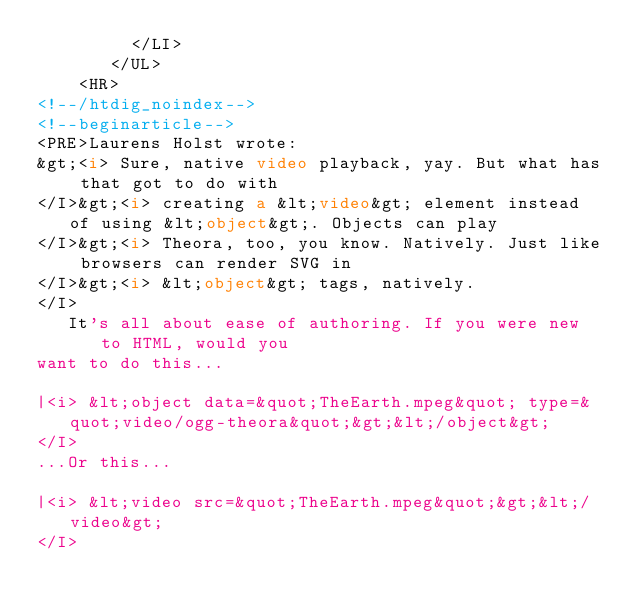Convert code to text. <code><loc_0><loc_0><loc_500><loc_500><_HTML_>         </LI>
       </UL>
    <HR>  
<!--/htdig_noindex-->
<!--beginarticle-->
<PRE>Laurens Holst wrote:
&gt;<i> Sure, native video playback, yay. But what has that got to do with 
</I>&gt;<i> creating a &lt;video&gt; element instead of using &lt;object&gt;. Objects can play 
</I>&gt;<i> Theora, too, you know. Natively. Just like browsers can render SVG in 
</I>&gt;<i> &lt;object&gt; tags, natively.
</I>
   It's all about ease of authoring. If you were new to HTML, would you
want to do this...

|<i> &lt;object data=&quot;TheEarth.mpeg&quot; type=&quot;video/ogg-theora&quot;&gt;&lt;/object&gt;
</I>
...Or this...

|<i> &lt;video src=&quot;TheEarth.mpeg&quot;&gt;&lt;/video&gt;
</I></code> 